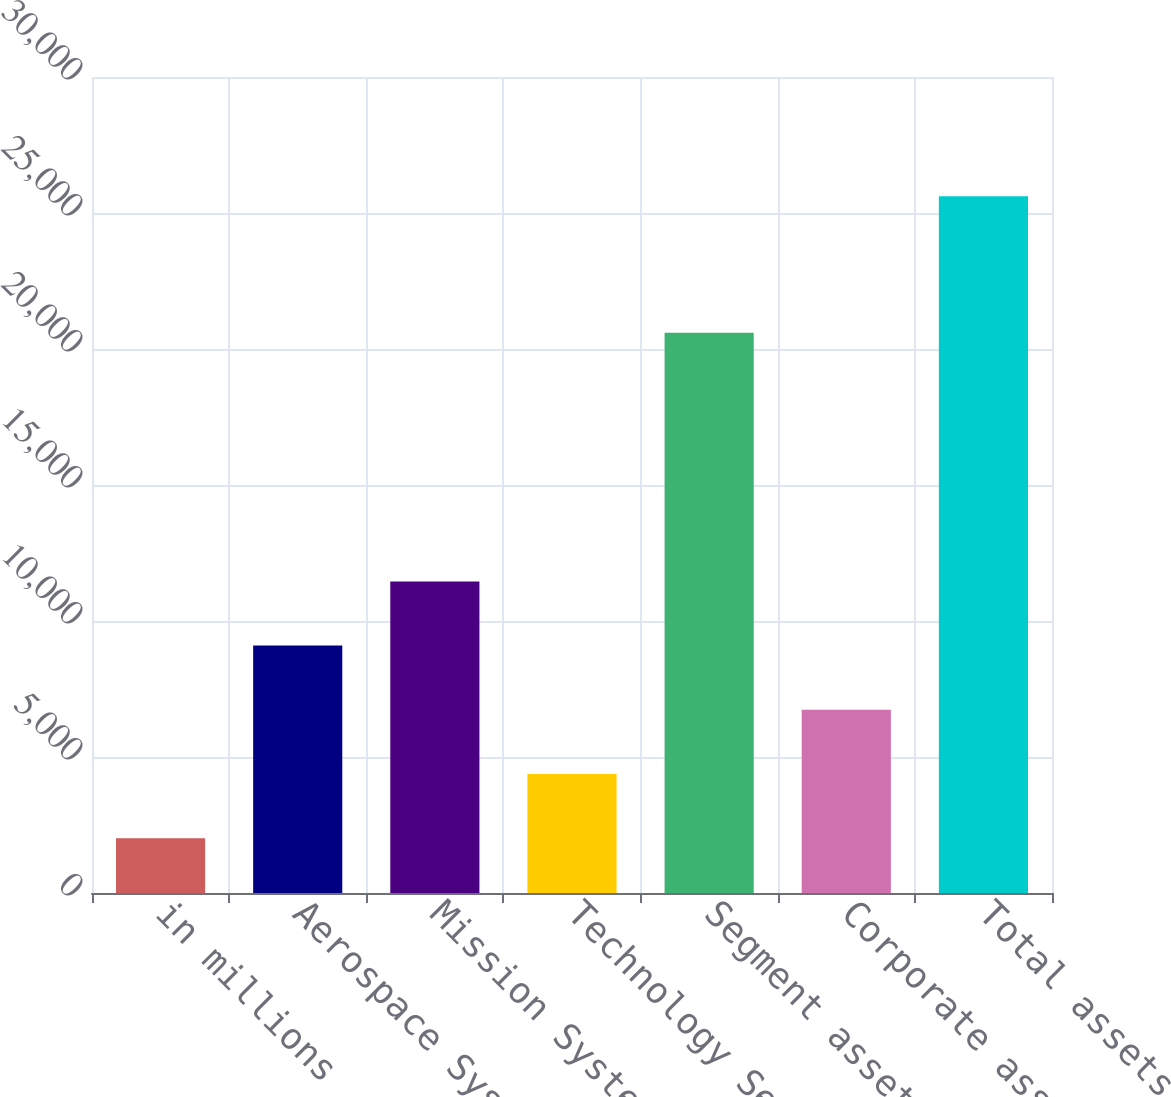Convert chart. <chart><loc_0><loc_0><loc_500><loc_500><bar_chart><fcel>in millions<fcel>Aerospace Systems<fcel>Mission Systems<fcel>Technology Services<fcel>Segment assets<fcel>Corporate assets (1)<fcel>Total assets<nl><fcel>2016<fcel>9095.4<fcel>11455.2<fcel>4375.8<fcel>20596<fcel>6735.6<fcel>25614<nl></chart> 